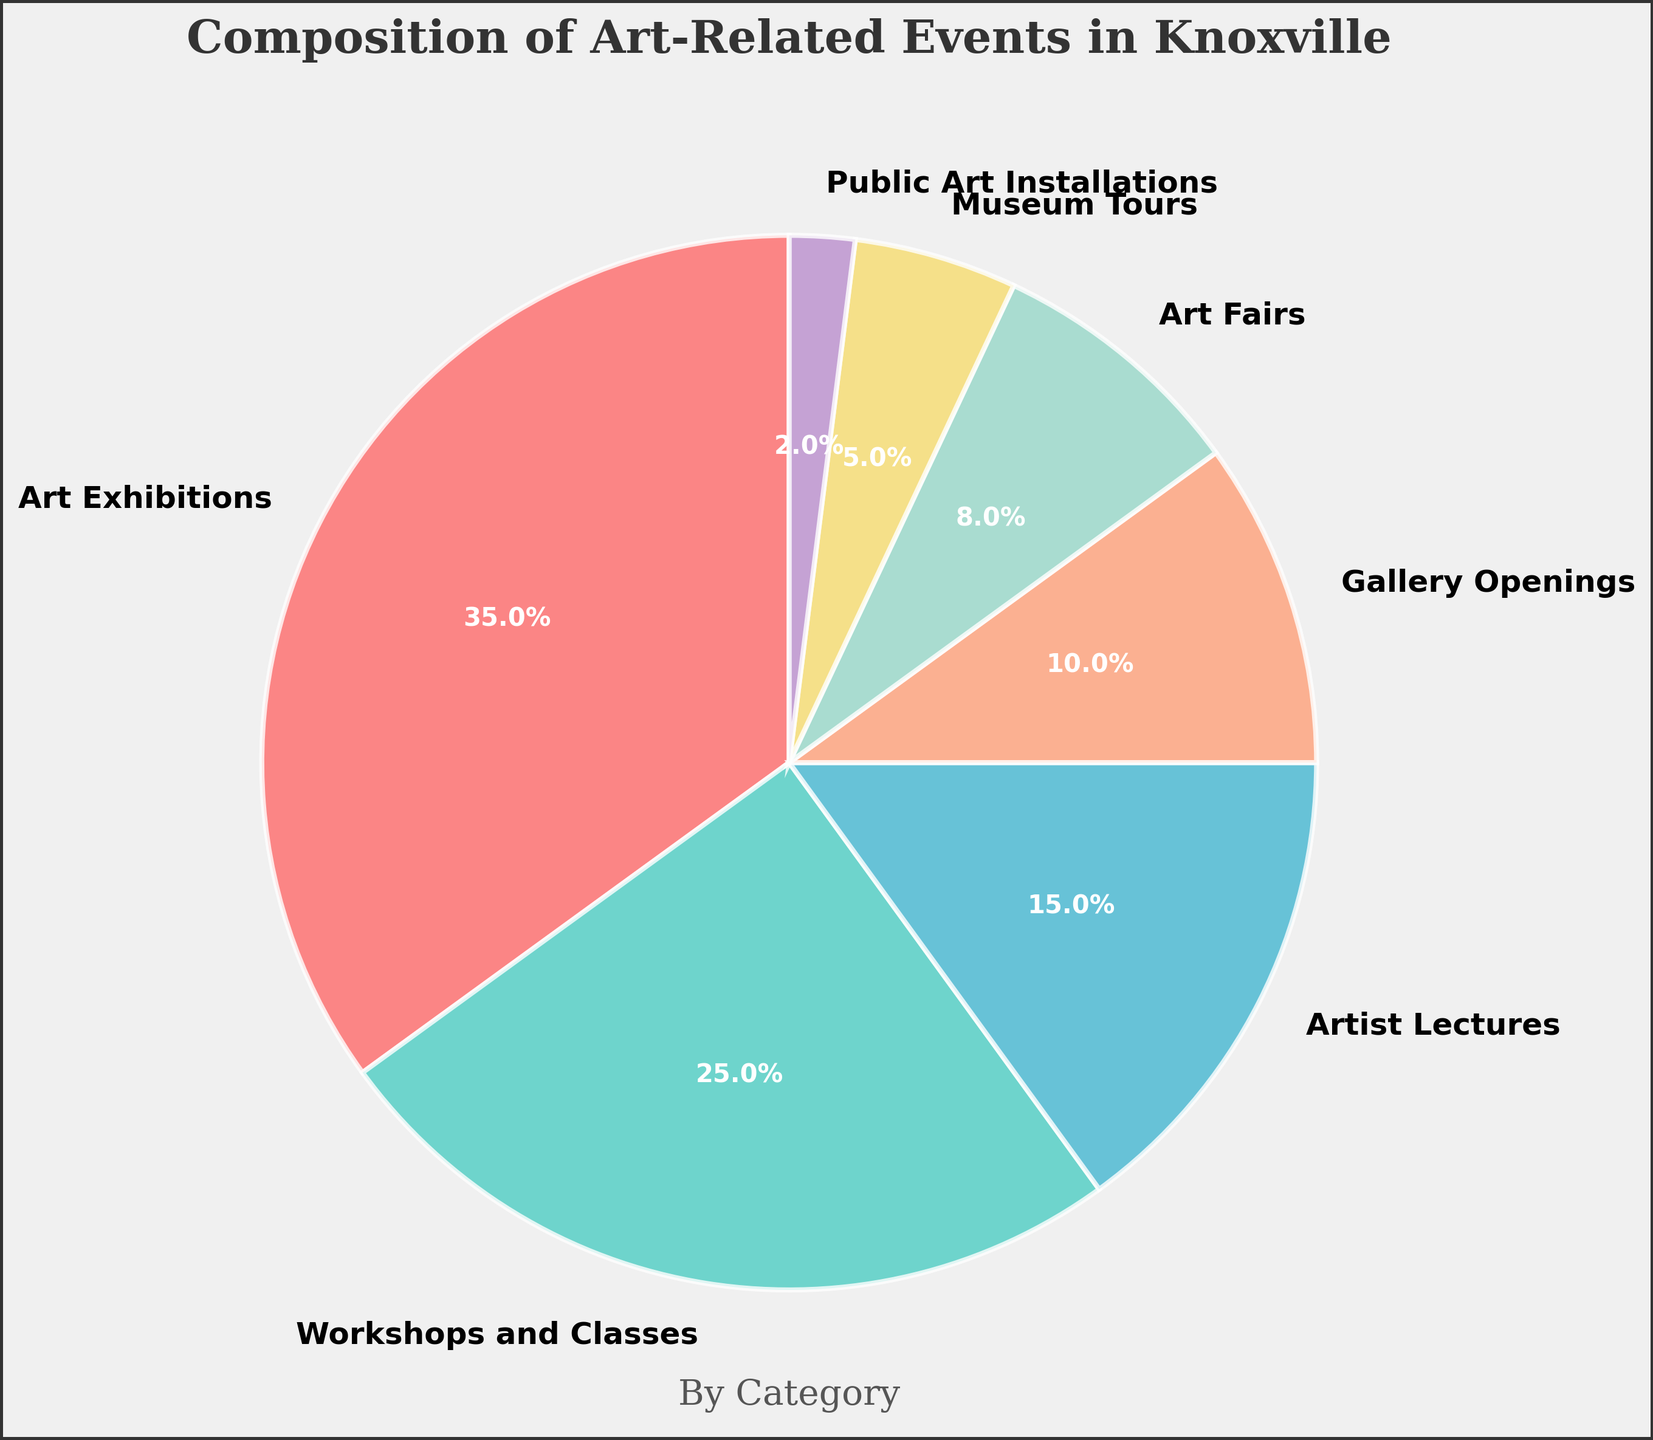What is the total percentage of events dedicated to artist lectures and museum tours combined? To find the total percentage, add the percentage of artist lectures and museum tours: 15% (Artist Lectures) + 5% (Museum Tours) = 20%.
Answer: 20% Which event category takes up the largest portion of the pie chart? By observing, the largest wedge represents Art Exhibitions, which is 35%.
Answer: Art Exhibitions How much greater is the percentage of workshops and classes compared to gallery openings? Subtract the percentage of gallery openings from workshops and classes: 25% (Workshops and Classes) - 10% (Gallery Openings) = 15%.
Answer: 15% Is the percentage of art fairs less than the percentage of artist lectures? Compare the percentages: 8% (Art Fairs) < 15% (Artist Lectures).
Answer: Yes By how much do the percentages of public art installations and museum tours differ? Calculate the difference: 5% (Museum Tours) - 2% (Public Art Installations) = 3%.
Answer: 3% Which three categories are represented by the green, yellow, and purple sections of the pie chart? Identify colors and match them with sections: green is Workshops and Classes, yellow is Museum Tours, and purple is Gallery Openings.
Answer: Workshops and Classes, Museum Tours, Gallery Openings What fraction of the pie chart is composed of art exhibitions alone? Art Exhibitions make up 35% of the total. To convert this to a fraction: 35% = 35/100 = 7/20.
Answer: 7/20 Are public art installations and art fairs represented by the same primary color? Public Art Installations (2%) are shown in red, and Art Fairs (8%) are shown in purple.
Answer: No What percentage of events do workshops and classes plus gallery openings make up? Sum the percentages: 25% (Workshops and Classes) + 10% (Gallery Openings) = 35%.
Answer: 35% Which visual attribute makes the pie chart more distinguishable for understanding different event types? The vibrant colors, wedge size, and clear labels highlight different event types effectively.
Answer: Vibrant colors, wedge size, clear labels 